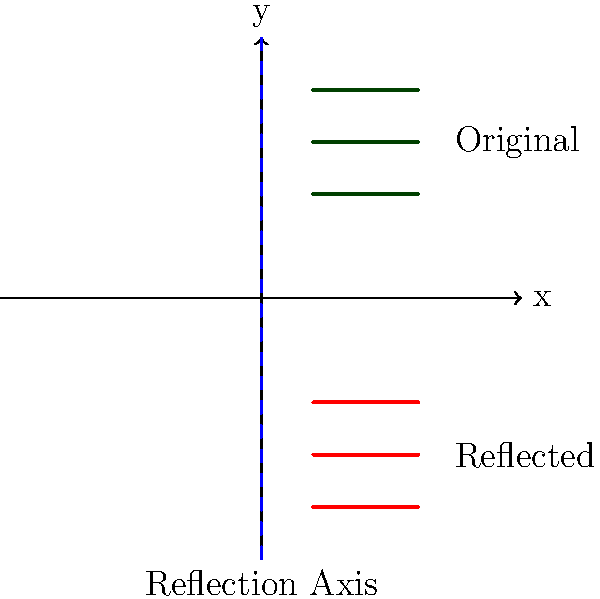As a young farmer planning an efficient irrigation system, you decide to reflect your crop rows across the x-axis to ensure equal water distribution. If the original crop rows are represented by the lines $y = 4$, $y = 3$, and $y = 2$, what are the equations of the reflected crop rows? To solve this problem, we need to understand the concept of reflection across the x-axis in transformational geometry. Here's a step-by-step explanation:

1) When reflecting a point $(x, y)$ across the x-axis, the x-coordinate remains the same, while the y-coordinate changes sign. The reflection of $(x, y)$ becomes $(x, -y)$.

2) For a horizontal line, the equation is in the form $y = k$, where $k$ is a constant.

3) The original crop rows are given by the equations:
   $y = 4$
   $y = 3$
   $y = 2$

4) To reflect these lines across the x-axis, we need to change the sign of the y-value in each equation:

   $y = 4$ becomes $y = -4$
   $y = 3$ becomes $y = -3$
   $y = 2$ becomes $y = -2$

5) These new equations represent the reflected crop rows.

Therefore, the equations of the reflected crop rows are $y = -4$, $y = -3$, and $y = -2$.
Answer: $y = -4$, $y = -3$, $y = -2$ 